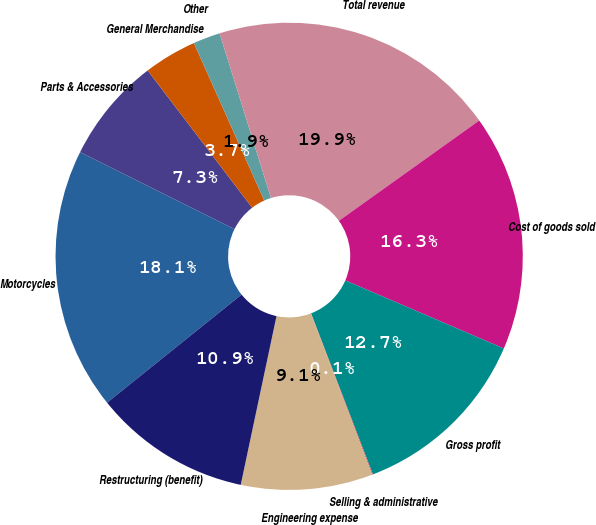Convert chart. <chart><loc_0><loc_0><loc_500><loc_500><pie_chart><fcel>Motorcycles<fcel>Parts & Accessories<fcel>General Merchandise<fcel>Other<fcel>Total revenue<fcel>Cost of goods sold<fcel>Gross profit<fcel>Selling & administrative<fcel>Engineering expense<fcel>Restructuring (benefit)<nl><fcel>18.13%<fcel>7.29%<fcel>3.67%<fcel>1.87%<fcel>19.94%<fcel>16.33%<fcel>12.71%<fcel>0.06%<fcel>9.1%<fcel>10.9%<nl></chart> 